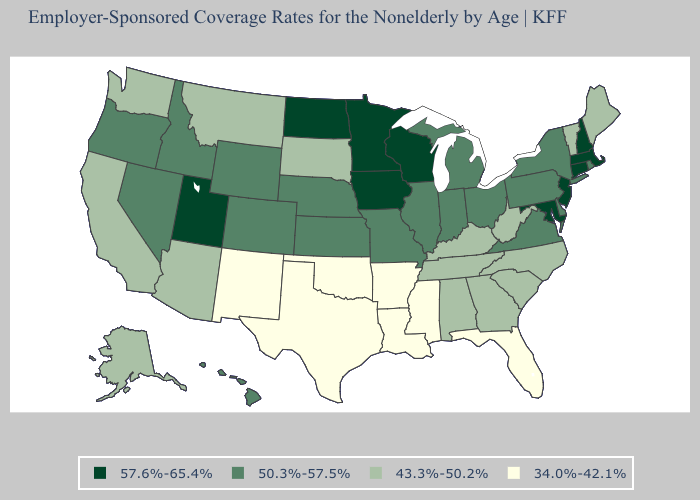What is the value of Arizona?
Answer briefly. 43.3%-50.2%. Does Michigan have the highest value in the USA?
Concise answer only. No. How many symbols are there in the legend?
Concise answer only. 4. Does New York have the highest value in the USA?
Write a very short answer. No. What is the highest value in the USA?
Give a very brief answer. 57.6%-65.4%. Name the states that have a value in the range 34.0%-42.1%?
Answer briefly. Arkansas, Florida, Louisiana, Mississippi, New Mexico, Oklahoma, Texas. Does Maryland have the highest value in the South?
Short answer required. Yes. Which states have the lowest value in the USA?
Give a very brief answer. Arkansas, Florida, Louisiana, Mississippi, New Mexico, Oklahoma, Texas. Does Maine have the highest value in the Northeast?
Quick response, please. No. What is the highest value in states that border Idaho?
Keep it brief. 57.6%-65.4%. Which states have the highest value in the USA?
Concise answer only. Connecticut, Iowa, Maryland, Massachusetts, Minnesota, New Hampshire, New Jersey, North Dakota, Utah, Wisconsin. Name the states that have a value in the range 57.6%-65.4%?
Write a very short answer. Connecticut, Iowa, Maryland, Massachusetts, Minnesota, New Hampshire, New Jersey, North Dakota, Utah, Wisconsin. Name the states that have a value in the range 57.6%-65.4%?
Write a very short answer. Connecticut, Iowa, Maryland, Massachusetts, Minnesota, New Hampshire, New Jersey, North Dakota, Utah, Wisconsin. 